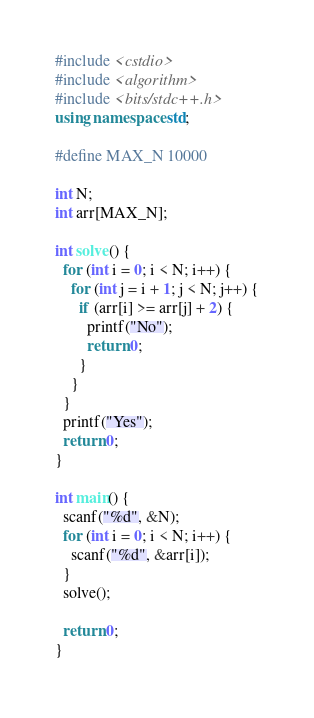<code> <loc_0><loc_0><loc_500><loc_500><_C++_>#include <cstdio>
#include <algorithm>
#include <bits/stdc++.h>
using namespace std;

#define MAX_N 10000

int N;
int arr[MAX_N];

int solve() {
  for (int i = 0; i < N; i++) {
    for (int j = i + 1; j < N; j++) {
      if (arr[i] >= arr[j] + 2) {
        printf("No");
        return 0;
      }
    }
  }
  printf("Yes");
  return 0;
}

int main() {
  scanf("%d", &N);
  for (int i = 0; i < N; i++) {
    scanf("%d", &arr[i]);
  }
  solve();
  
  return 0;
}</code> 